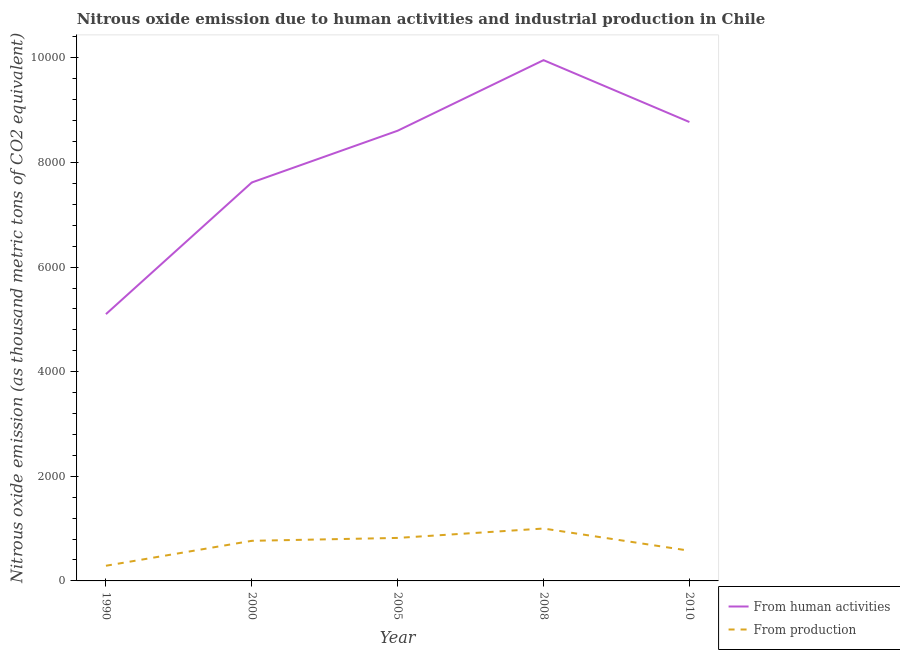Does the line corresponding to amount of emissions generated from industries intersect with the line corresponding to amount of emissions from human activities?
Give a very brief answer. No. Is the number of lines equal to the number of legend labels?
Provide a succinct answer. Yes. What is the amount of emissions from human activities in 2008?
Keep it short and to the point. 9956.7. Across all years, what is the maximum amount of emissions from human activities?
Provide a short and direct response. 9956.7. Across all years, what is the minimum amount of emissions from human activities?
Make the answer very short. 5100.7. What is the total amount of emissions generated from industries in the graph?
Offer a terse response. 3458.4. What is the difference between the amount of emissions generated from industries in 2000 and that in 2008?
Your answer should be very brief. -234.9. What is the difference between the amount of emissions from human activities in 2005 and the amount of emissions generated from industries in 1990?
Provide a short and direct response. 8317.5. What is the average amount of emissions generated from industries per year?
Your response must be concise. 691.68. In the year 1990, what is the difference between the amount of emissions from human activities and amount of emissions generated from industries?
Keep it short and to the point. 4810.6. What is the ratio of the amount of emissions from human activities in 2005 to that in 2008?
Give a very brief answer. 0.86. Is the amount of emissions from human activities in 1990 less than that in 2005?
Provide a succinct answer. Yes. What is the difference between the highest and the second highest amount of emissions from human activities?
Give a very brief answer. 1182.9. What is the difference between the highest and the lowest amount of emissions generated from industries?
Your answer should be very brief. 711.7. In how many years, is the amount of emissions generated from industries greater than the average amount of emissions generated from industries taken over all years?
Provide a succinct answer. 3. Is the amount of emissions generated from industries strictly less than the amount of emissions from human activities over the years?
Make the answer very short. Yes. How many lines are there?
Your answer should be compact. 2. How many years are there in the graph?
Give a very brief answer. 5. Are the values on the major ticks of Y-axis written in scientific E-notation?
Offer a terse response. No. Does the graph contain any zero values?
Your answer should be compact. No. Where does the legend appear in the graph?
Ensure brevity in your answer.  Bottom right. How many legend labels are there?
Your answer should be very brief. 2. How are the legend labels stacked?
Provide a short and direct response. Vertical. What is the title of the graph?
Offer a very short reply. Nitrous oxide emission due to human activities and industrial production in Chile. What is the label or title of the Y-axis?
Your answer should be compact. Nitrous oxide emission (as thousand metric tons of CO2 equivalent). What is the Nitrous oxide emission (as thousand metric tons of CO2 equivalent) in From human activities in 1990?
Your answer should be very brief. 5100.7. What is the Nitrous oxide emission (as thousand metric tons of CO2 equivalent) in From production in 1990?
Ensure brevity in your answer.  290.1. What is the Nitrous oxide emission (as thousand metric tons of CO2 equivalent) of From human activities in 2000?
Keep it short and to the point. 7617.9. What is the Nitrous oxide emission (as thousand metric tons of CO2 equivalent) of From production in 2000?
Keep it short and to the point. 766.9. What is the Nitrous oxide emission (as thousand metric tons of CO2 equivalent) in From human activities in 2005?
Provide a short and direct response. 8607.6. What is the Nitrous oxide emission (as thousand metric tons of CO2 equivalent) in From production in 2005?
Provide a succinct answer. 822.2. What is the Nitrous oxide emission (as thousand metric tons of CO2 equivalent) of From human activities in 2008?
Your response must be concise. 9956.7. What is the Nitrous oxide emission (as thousand metric tons of CO2 equivalent) of From production in 2008?
Make the answer very short. 1001.8. What is the Nitrous oxide emission (as thousand metric tons of CO2 equivalent) of From human activities in 2010?
Your response must be concise. 8773.8. What is the Nitrous oxide emission (as thousand metric tons of CO2 equivalent) in From production in 2010?
Make the answer very short. 577.4. Across all years, what is the maximum Nitrous oxide emission (as thousand metric tons of CO2 equivalent) of From human activities?
Offer a very short reply. 9956.7. Across all years, what is the maximum Nitrous oxide emission (as thousand metric tons of CO2 equivalent) of From production?
Offer a terse response. 1001.8. Across all years, what is the minimum Nitrous oxide emission (as thousand metric tons of CO2 equivalent) of From human activities?
Provide a short and direct response. 5100.7. Across all years, what is the minimum Nitrous oxide emission (as thousand metric tons of CO2 equivalent) of From production?
Ensure brevity in your answer.  290.1. What is the total Nitrous oxide emission (as thousand metric tons of CO2 equivalent) of From human activities in the graph?
Provide a succinct answer. 4.01e+04. What is the total Nitrous oxide emission (as thousand metric tons of CO2 equivalent) of From production in the graph?
Offer a very short reply. 3458.4. What is the difference between the Nitrous oxide emission (as thousand metric tons of CO2 equivalent) in From human activities in 1990 and that in 2000?
Make the answer very short. -2517.2. What is the difference between the Nitrous oxide emission (as thousand metric tons of CO2 equivalent) in From production in 1990 and that in 2000?
Give a very brief answer. -476.8. What is the difference between the Nitrous oxide emission (as thousand metric tons of CO2 equivalent) of From human activities in 1990 and that in 2005?
Give a very brief answer. -3506.9. What is the difference between the Nitrous oxide emission (as thousand metric tons of CO2 equivalent) of From production in 1990 and that in 2005?
Provide a short and direct response. -532.1. What is the difference between the Nitrous oxide emission (as thousand metric tons of CO2 equivalent) in From human activities in 1990 and that in 2008?
Your answer should be very brief. -4856. What is the difference between the Nitrous oxide emission (as thousand metric tons of CO2 equivalent) in From production in 1990 and that in 2008?
Make the answer very short. -711.7. What is the difference between the Nitrous oxide emission (as thousand metric tons of CO2 equivalent) of From human activities in 1990 and that in 2010?
Keep it short and to the point. -3673.1. What is the difference between the Nitrous oxide emission (as thousand metric tons of CO2 equivalent) of From production in 1990 and that in 2010?
Your response must be concise. -287.3. What is the difference between the Nitrous oxide emission (as thousand metric tons of CO2 equivalent) of From human activities in 2000 and that in 2005?
Your answer should be very brief. -989.7. What is the difference between the Nitrous oxide emission (as thousand metric tons of CO2 equivalent) in From production in 2000 and that in 2005?
Provide a short and direct response. -55.3. What is the difference between the Nitrous oxide emission (as thousand metric tons of CO2 equivalent) in From human activities in 2000 and that in 2008?
Give a very brief answer. -2338.8. What is the difference between the Nitrous oxide emission (as thousand metric tons of CO2 equivalent) in From production in 2000 and that in 2008?
Your answer should be compact. -234.9. What is the difference between the Nitrous oxide emission (as thousand metric tons of CO2 equivalent) of From human activities in 2000 and that in 2010?
Your response must be concise. -1155.9. What is the difference between the Nitrous oxide emission (as thousand metric tons of CO2 equivalent) of From production in 2000 and that in 2010?
Offer a very short reply. 189.5. What is the difference between the Nitrous oxide emission (as thousand metric tons of CO2 equivalent) in From human activities in 2005 and that in 2008?
Keep it short and to the point. -1349.1. What is the difference between the Nitrous oxide emission (as thousand metric tons of CO2 equivalent) in From production in 2005 and that in 2008?
Your answer should be very brief. -179.6. What is the difference between the Nitrous oxide emission (as thousand metric tons of CO2 equivalent) in From human activities in 2005 and that in 2010?
Your response must be concise. -166.2. What is the difference between the Nitrous oxide emission (as thousand metric tons of CO2 equivalent) of From production in 2005 and that in 2010?
Your answer should be very brief. 244.8. What is the difference between the Nitrous oxide emission (as thousand metric tons of CO2 equivalent) in From human activities in 2008 and that in 2010?
Offer a very short reply. 1182.9. What is the difference between the Nitrous oxide emission (as thousand metric tons of CO2 equivalent) of From production in 2008 and that in 2010?
Make the answer very short. 424.4. What is the difference between the Nitrous oxide emission (as thousand metric tons of CO2 equivalent) in From human activities in 1990 and the Nitrous oxide emission (as thousand metric tons of CO2 equivalent) in From production in 2000?
Make the answer very short. 4333.8. What is the difference between the Nitrous oxide emission (as thousand metric tons of CO2 equivalent) of From human activities in 1990 and the Nitrous oxide emission (as thousand metric tons of CO2 equivalent) of From production in 2005?
Make the answer very short. 4278.5. What is the difference between the Nitrous oxide emission (as thousand metric tons of CO2 equivalent) of From human activities in 1990 and the Nitrous oxide emission (as thousand metric tons of CO2 equivalent) of From production in 2008?
Your answer should be compact. 4098.9. What is the difference between the Nitrous oxide emission (as thousand metric tons of CO2 equivalent) of From human activities in 1990 and the Nitrous oxide emission (as thousand metric tons of CO2 equivalent) of From production in 2010?
Your answer should be compact. 4523.3. What is the difference between the Nitrous oxide emission (as thousand metric tons of CO2 equivalent) of From human activities in 2000 and the Nitrous oxide emission (as thousand metric tons of CO2 equivalent) of From production in 2005?
Offer a very short reply. 6795.7. What is the difference between the Nitrous oxide emission (as thousand metric tons of CO2 equivalent) in From human activities in 2000 and the Nitrous oxide emission (as thousand metric tons of CO2 equivalent) in From production in 2008?
Keep it short and to the point. 6616.1. What is the difference between the Nitrous oxide emission (as thousand metric tons of CO2 equivalent) in From human activities in 2000 and the Nitrous oxide emission (as thousand metric tons of CO2 equivalent) in From production in 2010?
Make the answer very short. 7040.5. What is the difference between the Nitrous oxide emission (as thousand metric tons of CO2 equivalent) of From human activities in 2005 and the Nitrous oxide emission (as thousand metric tons of CO2 equivalent) of From production in 2008?
Give a very brief answer. 7605.8. What is the difference between the Nitrous oxide emission (as thousand metric tons of CO2 equivalent) of From human activities in 2005 and the Nitrous oxide emission (as thousand metric tons of CO2 equivalent) of From production in 2010?
Your response must be concise. 8030.2. What is the difference between the Nitrous oxide emission (as thousand metric tons of CO2 equivalent) of From human activities in 2008 and the Nitrous oxide emission (as thousand metric tons of CO2 equivalent) of From production in 2010?
Offer a terse response. 9379.3. What is the average Nitrous oxide emission (as thousand metric tons of CO2 equivalent) of From human activities per year?
Give a very brief answer. 8011.34. What is the average Nitrous oxide emission (as thousand metric tons of CO2 equivalent) of From production per year?
Your response must be concise. 691.68. In the year 1990, what is the difference between the Nitrous oxide emission (as thousand metric tons of CO2 equivalent) in From human activities and Nitrous oxide emission (as thousand metric tons of CO2 equivalent) in From production?
Your response must be concise. 4810.6. In the year 2000, what is the difference between the Nitrous oxide emission (as thousand metric tons of CO2 equivalent) of From human activities and Nitrous oxide emission (as thousand metric tons of CO2 equivalent) of From production?
Your answer should be very brief. 6851. In the year 2005, what is the difference between the Nitrous oxide emission (as thousand metric tons of CO2 equivalent) in From human activities and Nitrous oxide emission (as thousand metric tons of CO2 equivalent) in From production?
Ensure brevity in your answer.  7785.4. In the year 2008, what is the difference between the Nitrous oxide emission (as thousand metric tons of CO2 equivalent) in From human activities and Nitrous oxide emission (as thousand metric tons of CO2 equivalent) in From production?
Your answer should be compact. 8954.9. In the year 2010, what is the difference between the Nitrous oxide emission (as thousand metric tons of CO2 equivalent) in From human activities and Nitrous oxide emission (as thousand metric tons of CO2 equivalent) in From production?
Offer a very short reply. 8196.4. What is the ratio of the Nitrous oxide emission (as thousand metric tons of CO2 equivalent) in From human activities in 1990 to that in 2000?
Give a very brief answer. 0.67. What is the ratio of the Nitrous oxide emission (as thousand metric tons of CO2 equivalent) in From production in 1990 to that in 2000?
Your response must be concise. 0.38. What is the ratio of the Nitrous oxide emission (as thousand metric tons of CO2 equivalent) of From human activities in 1990 to that in 2005?
Ensure brevity in your answer.  0.59. What is the ratio of the Nitrous oxide emission (as thousand metric tons of CO2 equivalent) of From production in 1990 to that in 2005?
Ensure brevity in your answer.  0.35. What is the ratio of the Nitrous oxide emission (as thousand metric tons of CO2 equivalent) in From human activities in 1990 to that in 2008?
Your response must be concise. 0.51. What is the ratio of the Nitrous oxide emission (as thousand metric tons of CO2 equivalent) of From production in 1990 to that in 2008?
Offer a very short reply. 0.29. What is the ratio of the Nitrous oxide emission (as thousand metric tons of CO2 equivalent) in From human activities in 1990 to that in 2010?
Provide a succinct answer. 0.58. What is the ratio of the Nitrous oxide emission (as thousand metric tons of CO2 equivalent) in From production in 1990 to that in 2010?
Your response must be concise. 0.5. What is the ratio of the Nitrous oxide emission (as thousand metric tons of CO2 equivalent) of From human activities in 2000 to that in 2005?
Offer a very short reply. 0.89. What is the ratio of the Nitrous oxide emission (as thousand metric tons of CO2 equivalent) of From production in 2000 to that in 2005?
Provide a succinct answer. 0.93. What is the ratio of the Nitrous oxide emission (as thousand metric tons of CO2 equivalent) in From human activities in 2000 to that in 2008?
Provide a short and direct response. 0.77. What is the ratio of the Nitrous oxide emission (as thousand metric tons of CO2 equivalent) of From production in 2000 to that in 2008?
Make the answer very short. 0.77. What is the ratio of the Nitrous oxide emission (as thousand metric tons of CO2 equivalent) of From human activities in 2000 to that in 2010?
Provide a short and direct response. 0.87. What is the ratio of the Nitrous oxide emission (as thousand metric tons of CO2 equivalent) in From production in 2000 to that in 2010?
Make the answer very short. 1.33. What is the ratio of the Nitrous oxide emission (as thousand metric tons of CO2 equivalent) of From human activities in 2005 to that in 2008?
Keep it short and to the point. 0.86. What is the ratio of the Nitrous oxide emission (as thousand metric tons of CO2 equivalent) of From production in 2005 to that in 2008?
Your answer should be very brief. 0.82. What is the ratio of the Nitrous oxide emission (as thousand metric tons of CO2 equivalent) in From human activities in 2005 to that in 2010?
Ensure brevity in your answer.  0.98. What is the ratio of the Nitrous oxide emission (as thousand metric tons of CO2 equivalent) of From production in 2005 to that in 2010?
Ensure brevity in your answer.  1.42. What is the ratio of the Nitrous oxide emission (as thousand metric tons of CO2 equivalent) of From human activities in 2008 to that in 2010?
Ensure brevity in your answer.  1.13. What is the ratio of the Nitrous oxide emission (as thousand metric tons of CO2 equivalent) of From production in 2008 to that in 2010?
Your answer should be compact. 1.74. What is the difference between the highest and the second highest Nitrous oxide emission (as thousand metric tons of CO2 equivalent) in From human activities?
Give a very brief answer. 1182.9. What is the difference between the highest and the second highest Nitrous oxide emission (as thousand metric tons of CO2 equivalent) in From production?
Keep it short and to the point. 179.6. What is the difference between the highest and the lowest Nitrous oxide emission (as thousand metric tons of CO2 equivalent) of From human activities?
Give a very brief answer. 4856. What is the difference between the highest and the lowest Nitrous oxide emission (as thousand metric tons of CO2 equivalent) in From production?
Offer a terse response. 711.7. 